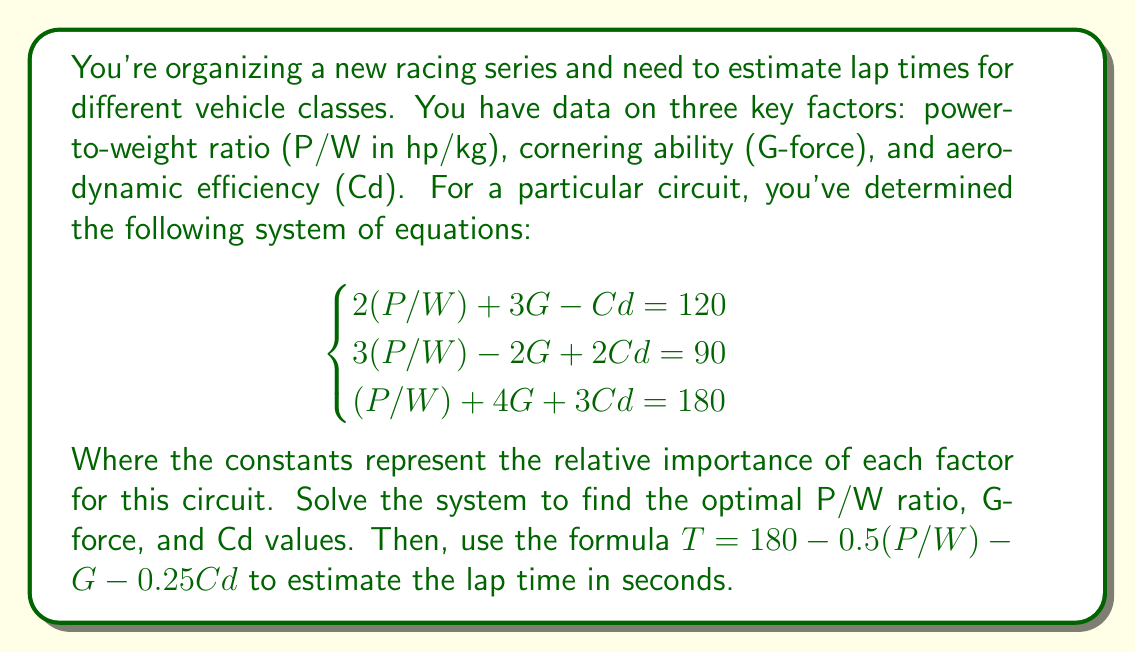Solve this math problem. Let's solve this step-by-step:

1) First, we need to solve the system of equations. We can use elimination or substitution method. Let's use elimination:

2) Multiply the first equation by 3 and the second equation by -2:
   $$\begin{cases}
   6(P/W) + 9G - 3Cd = 360 \\
   -6(P/W) + 4G - 4Cd = -180
   \end{cases}$$

3) Add these equations:
   $$13G - 7Cd = 180$$

4) Now, multiply the original first equation by 3 and the third equation by -2:
   $$\begin{cases}
   6(P/W) + 9G - 3Cd = 360 \\
   -2(P/W) - 8G - 6Cd = -360
   \end{cases}$$

5) Add these equations:
   $$4(P/W) + G - 9Cd = 0$$

6) We now have two equations with three unknowns:
   $$\begin{cases}
   13G - 7Cd = 180 \\
   4(P/W) + G - 9Cd = 0
   \end{cases}$$

7) Multiply the second equation by 13 and subtract the first equation:
   $$52(P/W) - 110Cd = -180$$

8) Divide by 2:
   $$26(P/W) - 55Cd = -90$$

9) From the original second equation:
   $$3(P/W) - 2G + 2Cd = 90$$
   Multiply by 26:
   $$78(P/W) - 52G + 52Cd = 2340$$

10) Subtract the equation from step 8:
    $$52(P/W) - 52G + 107Cd = 2430$$

11) Divide by 52:
    $$(P/W) - G + \frac{107}{52}Cd = \frac{2430}{52}$$

12) From the original first equation:
    $$2(P/W) + 3G - Cd = 120$$
    Subtract the equation from step 11:
    $$(P/W) + 4G - \frac{159}{52}Cd = \frac{2970}{52}$$

13) This matches the original third equation, so our solution is consistent.

14) From step 11:
    $$(P/W) = G - \frac{107}{52}Cd + \frac{2430}{52}$$

15) Substitute this into the original first equation:
    $$2(G - \frac{107}{52}Cd + \frac{2430}{52}) + 3G - Cd = 120$$
    $$2G - \frac{107}{26}Cd + \frac{2430}{26} + 3G - Cd = 120$$
    $$5G - \frac{133}{26}Cd = 120 - \frac{2430}{26}$$
    $$5G - \frac{133}{26}Cd = -\frac{1770}{26}$$

16) Multiply the equation from step 3 by 5:
    $$65G - 35Cd = 900$$

17) Subtract the equation from step 15:
    $$\frac{3458}{26}Cd = \frac{25170}{26}$$
    $$Cd = \frac{25170}{3458} \approx 7.28$$

18) Substitute this back into the equation from step 3:
    $$13G - 7(7.28) = 180$$
    $$13G = 230.96$$
    $$G = 17.77$$

19) Finally, substitute G and Cd into the equation from step 14:
    $$(P/W) = 17.77 - \frac{107}{52}(7.28) + \frac{2430}{52} \approx 60.45$$

20) Now we can use the formula to estimate the lap time:
    $$T = 180 - 0.5(P/W) - G - 0.25Cd$$
    $$T = 180 - 0.5(60.45) - 17.77 - 0.25(7.28)$$
    $$T = 180 - 30.23 - 17.77 - 1.82$$
    $$T = 130.18$$
Answer: 130.18 seconds 